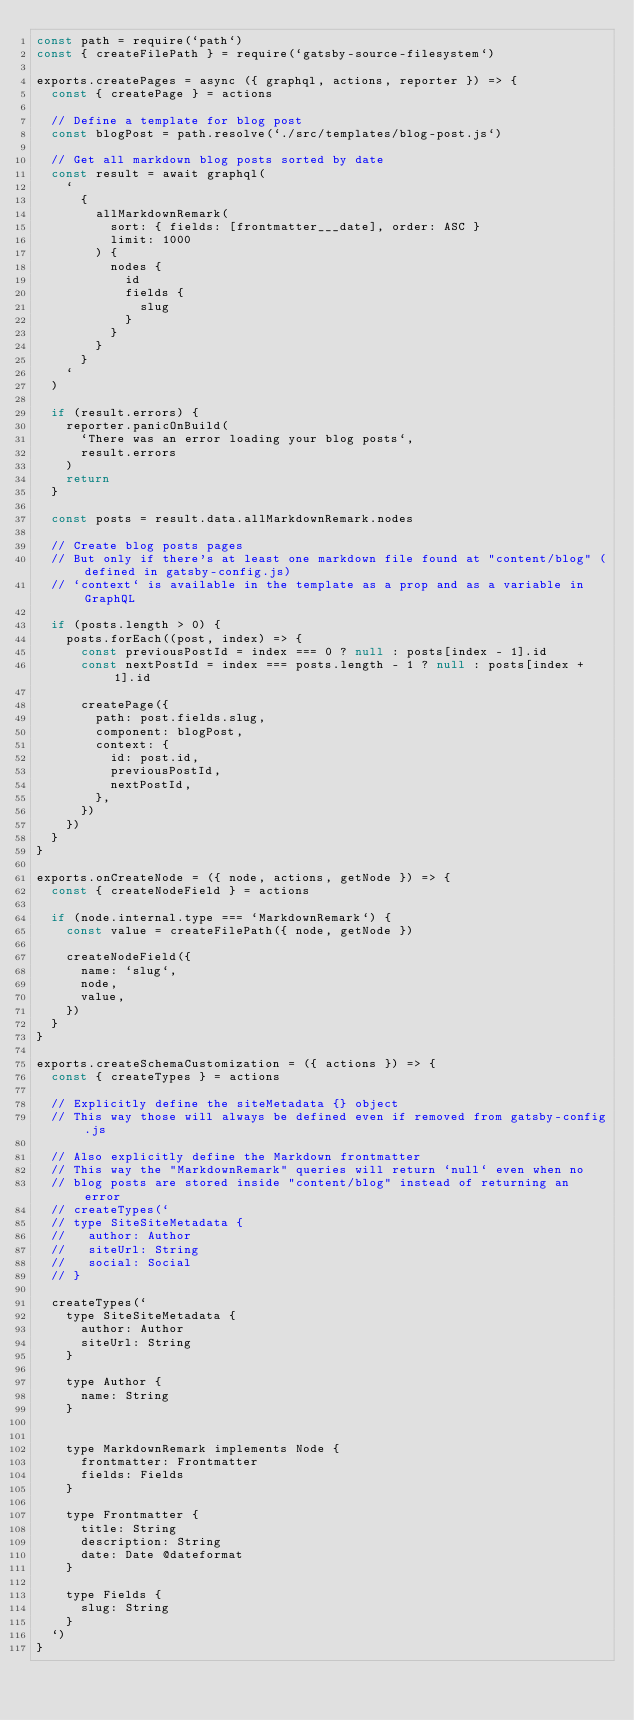<code> <loc_0><loc_0><loc_500><loc_500><_JavaScript_>const path = require(`path`)
const { createFilePath } = require(`gatsby-source-filesystem`)

exports.createPages = async ({ graphql, actions, reporter }) => {
  const { createPage } = actions

  // Define a template for blog post
  const blogPost = path.resolve(`./src/templates/blog-post.js`)

  // Get all markdown blog posts sorted by date
  const result = await graphql(
    `
      {
        allMarkdownRemark(
          sort: { fields: [frontmatter___date], order: ASC }
          limit: 1000
        ) {
          nodes {
            id
            fields {
              slug
            }
          }
        }
      }
    `
  )

  if (result.errors) {
    reporter.panicOnBuild(
      `There was an error loading your blog posts`,
      result.errors
    )
    return
  }

  const posts = result.data.allMarkdownRemark.nodes

  // Create blog posts pages
  // But only if there's at least one markdown file found at "content/blog" (defined in gatsby-config.js)
  // `context` is available in the template as a prop and as a variable in GraphQL

  if (posts.length > 0) {
    posts.forEach((post, index) => {
      const previousPostId = index === 0 ? null : posts[index - 1].id
      const nextPostId = index === posts.length - 1 ? null : posts[index + 1].id

      createPage({
        path: post.fields.slug,
        component: blogPost,
        context: {
          id: post.id,
          previousPostId,
          nextPostId,
        },
      })
    })
  }
}

exports.onCreateNode = ({ node, actions, getNode }) => {
  const { createNodeField } = actions

  if (node.internal.type === `MarkdownRemark`) {
    const value = createFilePath({ node, getNode })

    createNodeField({
      name: `slug`,
      node,
      value,
    })
  }
}

exports.createSchemaCustomization = ({ actions }) => {
  const { createTypes } = actions

  // Explicitly define the siteMetadata {} object
  // This way those will always be defined even if removed from gatsby-config.js

  // Also explicitly define the Markdown frontmatter
  // This way the "MarkdownRemark" queries will return `null` even when no
  // blog posts are stored inside "content/blog" instead of returning an error
  // createTypes(`
  // type SiteSiteMetadata {
  //   author: Author
  //   siteUrl: String
  //   social: Social
  // }

  createTypes(`
    type SiteSiteMetadata {
      author: Author
      siteUrl: String
    }

    type Author {
      name: String
    }


    type MarkdownRemark implements Node {
      frontmatter: Frontmatter
      fields: Fields
    }

    type Frontmatter {
      title: String
      description: String
      date: Date @dateformat
    }

    type Fields {
      slug: String
    }
  `)
}
</code> 